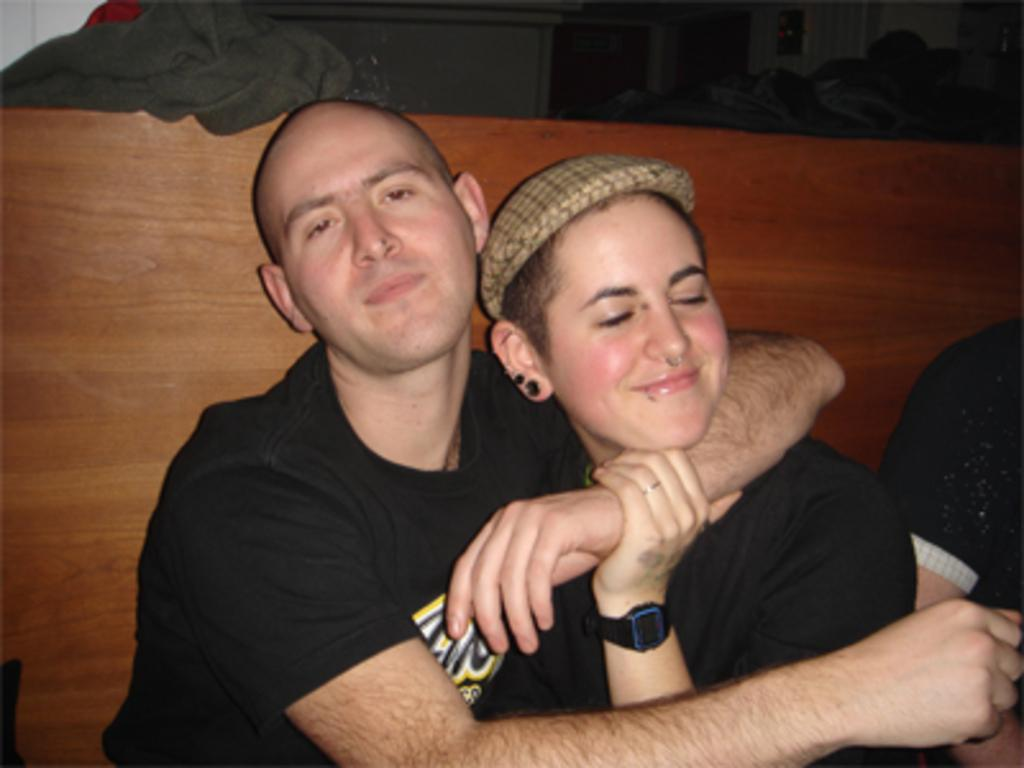How many people are in the image? There are people in the image, but the exact number is not specified. What is one of the people wearing? One of the people is wearing a cap. What can be seen in the background of the image? There is a board and a cloth visible in the background of the image. What other objects are present in the image? There are other objects present in the image, but their specific details are not mentioned. What type of property is being heated by the bat in the image? There is no property, heat, or bat present in the image. 